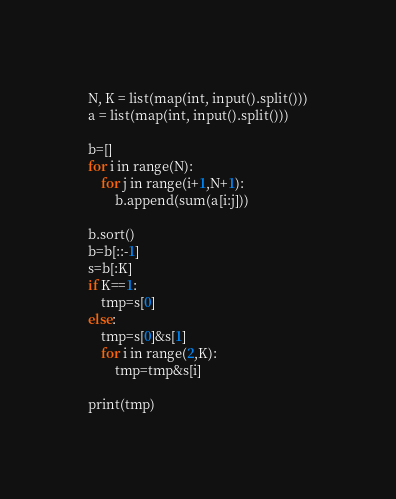Convert code to text. <code><loc_0><loc_0><loc_500><loc_500><_Python_>N, K = list(map(int, input().split()))
a = list(map(int, input().split()))

b=[]
for i in range(N):
    for j in range(i+1,N+1):
        b.append(sum(a[i:j]))

b.sort()
b=b[::-1]
s=b[:K]
if K==1:
    tmp=s[0]
else:
    tmp=s[0]&s[1]
    for i in range(2,K):
        tmp=tmp&s[i]

print(tmp)</code> 